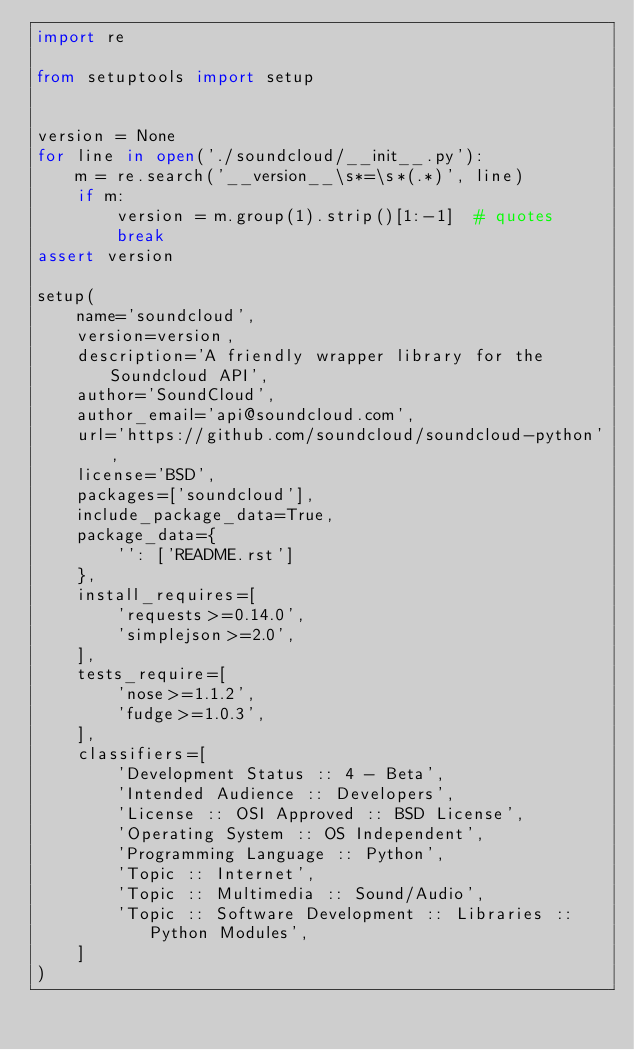<code> <loc_0><loc_0><loc_500><loc_500><_Python_>import re

from setuptools import setup


version = None
for line in open('./soundcloud/__init__.py'):
    m = re.search('__version__\s*=\s*(.*)', line)
    if m:
        version = m.group(1).strip()[1:-1]  # quotes
        break
assert version

setup(
    name='soundcloud',
    version=version,
    description='A friendly wrapper library for the Soundcloud API',
    author='SoundCloud',
    author_email='api@soundcloud.com',
    url='https://github.com/soundcloud/soundcloud-python',
    license='BSD',
    packages=['soundcloud'],
    include_package_data=True,
    package_data={
        '': ['README.rst']
    },
    install_requires=[
        'requests>=0.14.0',
        'simplejson>=2.0',
    ],
    tests_require=[
        'nose>=1.1.2',
        'fudge>=1.0.3',
    ],
    classifiers=[
        'Development Status :: 4 - Beta',
        'Intended Audience :: Developers',
        'License :: OSI Approved :: BSD License',
        'Operating System :: OS Independent',
        'Programming Language :: Python',
        'Topic :: Internet',
        'Topic :: Multimedia :: Sound/Audio',
        'Topic :: Software Development :: Libraries :: Python Modules',
    ]
)
</code> 